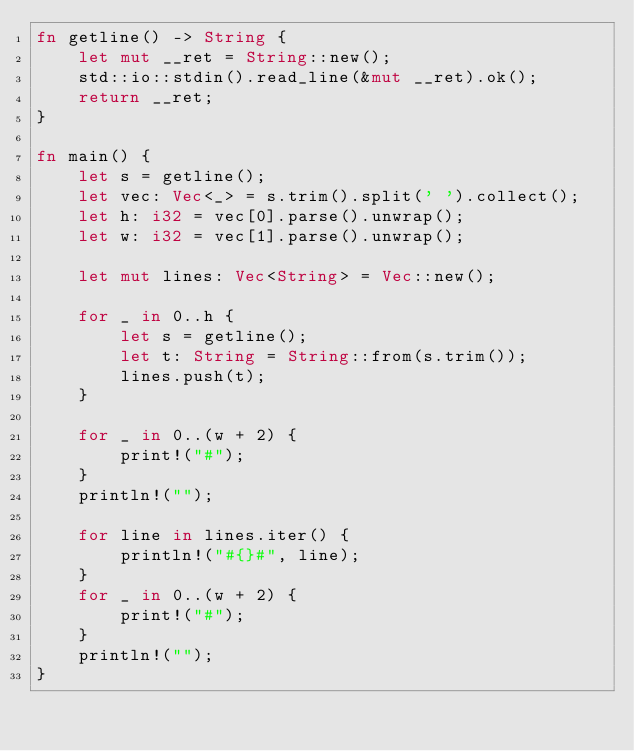Convert code to text. <code><loc_0><loc_0><loc_500><loc_500><_Rust_>fn getline() -> String {
    let mut __ret = String::new();
    std::io::stdin().read_line(&mut __ret).ok();
    return __ret;
}

fn main() {
    let s = getline();
    let vec: Vec<_> = s.trim().split(' ').collect();
    let h: i32 = vec[0].parse().unwrap();
    let w: i32 = vec[1].parse().unwrap();

    let mut lines: Vec<String> = Vec::new();

    for _ in 0..h {
        let s = getline();
        let t: String = String::from(s.trim());
        lines.push(t);
    }

    for _ in 0..(w + 2) {
        print!("#");
    }
    println!("");

    for line in lines.iter() {
        println!("#{}#", line);
    }
    for _ in 0..(w + 2) {
        print!("#");
    }
    println!("");
}
</code> 